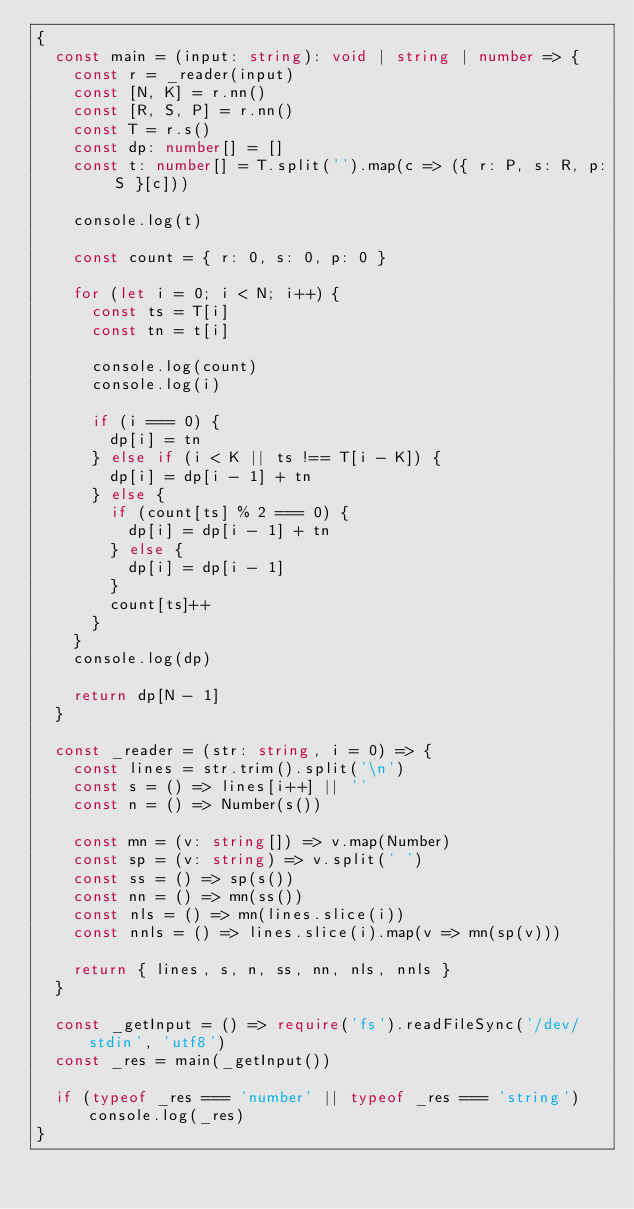Convert code to text. <code><loc_0><loc_0><loc_500><loc_500><_TypeScript_>{
  const main = (input: string): void | string | number => {
    const r = _reader(input)
    const [N, K] = r.nn()
    const [R, S, P] = r.nn()
    const T = r.s()
    const dp: number[] = []
    const t: number[] = T.split('').map(c => ({ r: P, s: R, p: S }[c]))

    console.log(t)

    const count = { r: 0, s: 0, p: 0 }

    for (let i = 0; i < N; i++) {
      const ts = T[i]
      const tn = t[i]

      console.log(count)
      console.log(i)

      if (i === 0) {
        dp[i] = tn
      } else if (i < K || ts !== T[i - K]) {
        dp[i] = dp[i - 1] + tn
      } else {
        if (count[ts] % 2 === 0) {
          dp[i] = dp[i - 1] + tn
        } else {
          dp[i] = dp[i - 1]
        }
        count[ts]++
      }
    }
    console.log(dp)

    return dp[N - 1]
  }

  const _reader = (str: string, i = 0) => {
    const lines = str.trim().split('\n')
    const s = () => lines[i++] || ''
    const n = () => Number(s())

    const mn = (v: string[]) => v.map(Number)
    const sp = (v: string) => v.split(' ')
    const ss = () => sp(s())
    const nn = () => mn(ss())
    const nls = () => mn(lines.slice(i))
    const nnls = () => lines.slice(i).map(v => mn(sp(v)))

    return { lines, s, n, ss, nn, nls, nnls }
  }

  const _getInput = () => require('fs').readFileSync('/dev/stdin', 'utf8')
  const _res = main(_getInput())

  if (typeof _res === 'number' || typeof _res === 'string') console.log(_res)
}
</code> 